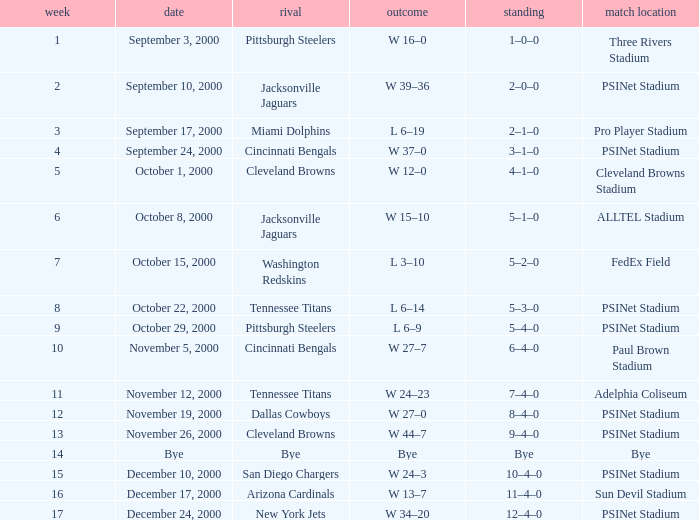What's the record after week 12 with a game site of bye? Bye. Could you help me parse every detail presented in this table? {'header': ['week', 'date', 'rival', 'outcome', 'standing', 'match location'], 'rows': [['1', 'September 3, 2000', 'Pittsburgh Steelers', 'W 16–0', '1–0–0', 'Three Rivers Stadium'], ['2', 'September 10, 2000', 'Jacksonville Jaguars', 'W 39–36', '2–0–0', 'PSINet Stadium'], ['3', 'September 17, 2000', 'Miami Dolphins', 'L 6–19', '2–1–0', 'Pro Player Stadium'], ['4', 'September 24, 2000', 'Cincinnati Bengals', 'W 37–0', '3–1–0', 'PSINet Stadium'], ['5', 'October 1, 2000', 'Cleveland Browns', 'W 12–0', '4–1–0', 'Cleveland Browns Stadium'], ['6', 'October 8, 2000', 'Jacksonville Jaguars', 'W 15–10', '5–1–0', 'ALLTEL Stadium'], ['7', 'October 15, 2000', 'Washington Redskins', 'L 3–10', '5–2–0', 'FedEx Field'], ['8', 'October 22, 2000', 'Tennessee Titans', 'L 6–14', '5–3–0', 'PSINet Stadium'], ['9', 'October 29, 2000', 'Pittsburgh Steelers', 'L 6–9', '5–4–0', 'PSINet Stadium'], ['10', 'November 5, 2000', 'Cincinnati Bengals', 'W 27–7', '6–4–0', 'Paul Brown Stadium'], ['11', 'November 12, 2000', 'Tennessee Titans', 'W 24–23', '7–4–0', 'Adelphia Coliseum'], ['12', 'November 19, 2000', 'Dallas Cowboys', 'W 27–0', '8–4–0', 'PSINet Stadium'], ['13', 'November 26, 2000', 'Cleveland Browns', 'W 44–7', '9–4–0', 'PSINet Stadium'], ['14', 'Bye', 'Bye', 'Bye', 'Bye', 'Bye'], ['15', 'December 10, 2000', 'San Diego Chargers', 'W 24–3', '10–4–0', 'PSINet Stadium'], ['16', 'December 17, 2000', 'Arizona Cardinals', 'W 13–7', '11–4–0', 'Sun Devil Stadium'], ['17', 'December 24, 2000', 'New York Jets', 'W 34–20', '12–4–0', 'PSINet Stadium']]} 